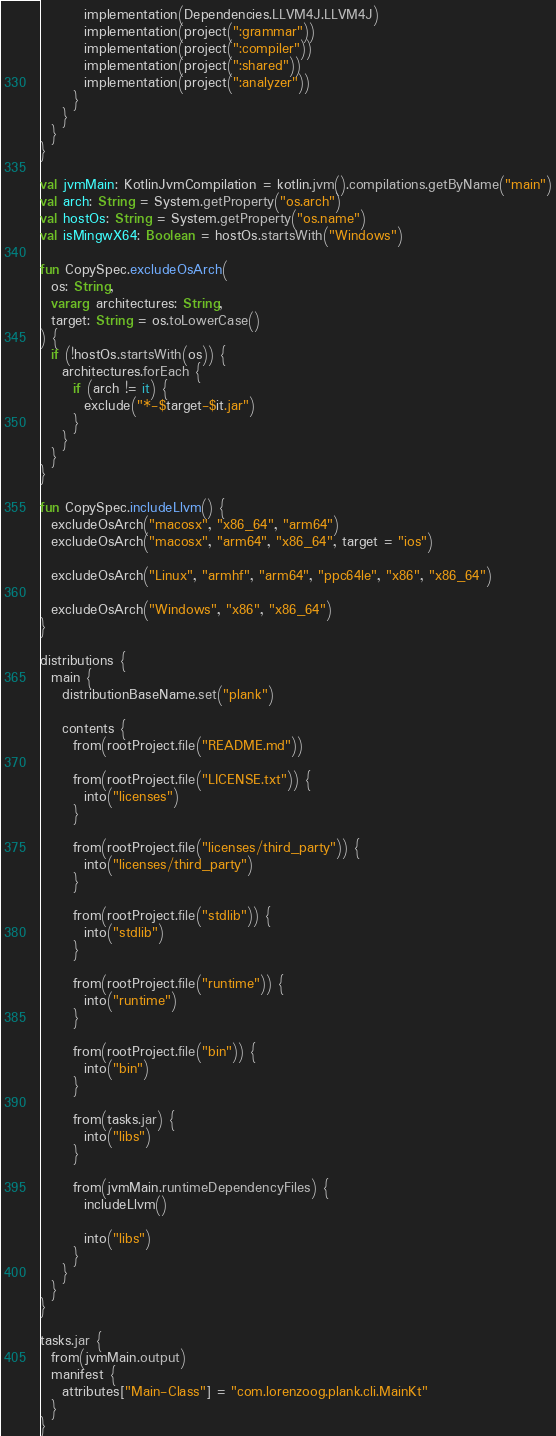Convert code to text. <code><loc_0><loc_0><loc_500><loc_500><_Kotlin_>        implementation(Dependencies.LLVM4J.LLVM4J)
        implementation(project(":grammar"))
        implementation(project(":compiler"))
        implementation(project(":shared"))
        implementation(project(":analyzer"))
      }
    }
  }
}

val jvmMain: KotlinJvmCompilation = kotlin.jvm().compilations.getByName("main")
val arch: String = System.getProperty("os.arch")
val hostOs: String = System.getProperty("os.name")
val isMingwX64: Boolean = hostOs.startsWith("Windows")

fun CopySpec.excludeOsArch(
  os: String,
  vararg architectures: String,
  target: String = os.toLowerCase()
) {
  if (!hostOs.startsWith(os)) {
    architectures.forEach {
      if (arch != it) {
        exclude("*-$target-$it.jar")
      }
    }
  }
}

fun CopySpec.includeLlvm() {
  excludeOsArch("macosx", "x86_64", "arm64")
  excludeOsArch("macosx", "arm64", "x86_64", target = "ios")

  excludeOsArch("Linux", "armhf", "arm64", "ppc64le", "x86", "x86_64")

  excludeOsArch("Windows", "x86", "x86_64")
}

distributions {
  main {
    distributionBaseName.set("plank")

    contents {
      from(rootProject.file("README.md"))

      from(rootProject.file("LICENSE.txt")) {
        into("licenses")
      }

      from(rootProject.file("licenses/third_party")) {
        into("licenses/third_party")
      }

      from(rootProject.file("stdlib")) {
        into("stdlib")
      }

      from(rootProject.file("runtime")) {
        into("runtime")
      }

      from(rootProject.file("bin")) {
        into("bin")
      }

      from(tasks.jar) {
        into("libs")
      }

      from(jvmMain.runtimeDependencyFiles) {
        includeLlvm()

        into("libs")
      }
    }
  }
}

tasks.jar {
  from(jvmMain.output)
  manifest {
    attributes["Main-Class"] = "com.lorenzoog.plank.cli.MainKt"
  }
}
</code> 